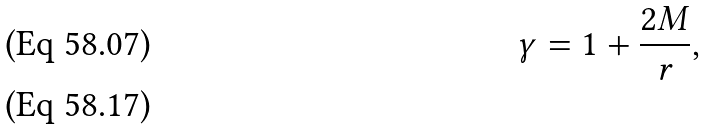<formula> <loc_0><loc_0><loc_500><loc_500>\gamma = 1 + \frac { 2 M } { r } , \\</formula> 